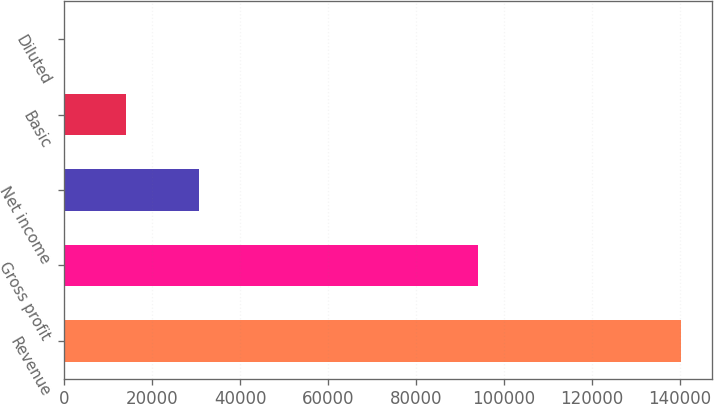Convert chart. <chart><loc_0><loc_0><loc_500><loc_500><bar_chart><fcel>Revenue<fcel>Gross profit<fcel>Net income<fcel>Basic<fcel>Diluted<nl><fcel>140249<fcel>94108<fcel>30663<fcel>14025.6<fcel>0.79<nl></chart> 